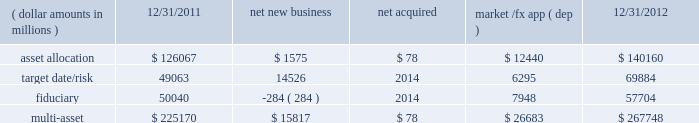Although many clients use both active and passive strategies , the application of these strategies differs greatly .
For example , clients may use index products to gain exposure to a market or asset class pending reallocation to an active manager .
This has the effect of increasing turnover of index aum .
In addition , institutional non-etp index assignments tend to be very large ( multi- billion dollars ) and typically reflect low fee rates .
This has the potential to exaggerate the significance of net flows in institutional index products on blackrock 2019s revenues and earnings .
Equity year-end 2012 equity aum of $ 1.845 trillion increased by $ 285.4 billion , or 18% ( 18 % ) , from the end of 2011 , largely due to flows into regional , country-specific and global mandates and the effect of higher market valuations .
Equity aum growth included $ 54.0 billion in net new business and $ 3.6 billion in new assets related to the acquisition of claymore .
Net new business of $ 54.0 billion was driven by net inflows of $ 53.0 billion and $ 19.1 billion into ishares and non-etp index accounts , respectively .
Passive inflows were offset by active net outflows of $ 18.1 billion , with net outflows of $ 10.0 billion and $ 8.1 billion from fundamental and scientific active equity products , respectively .
Passive strategies represented 84% ( 84 % ) of equity aum with the remaining 16% ( 16 % ) in active mandates .
Institutional investors represented 62% ( 62 % ) of equity aum , while ishares , and retail and hnw represented 29% ( 29 % ) and 9% ( 9 % ) , respectively .
At year-end 2012 , 63% ( 63 % ) of equity aum was managed for clients in the americas ( defined as the united states , caribbean , canada , latin america and iberia ) compared with 28% ( 28 % ) and 9% ( 9 % ) managed for clients in emea and asia-pacific , respectively .
Blackrock 2019s effective fee rates fluctuate due to changes in aum mix .
Approximately half of blackrock 2019s equity aum is tied to international markets , including emerging markets , which tend to have higher fee rates than similar u.s .
Equity strategies .
Accordingly , fluctuations in international equity markets , which do not consistently move in tandem with u.s .
Markets , may have a greater impact on blackrock 2019s effective equity fee rates and revenues .
Fixed income fixed income aum ended 2012 at $ 1.259 trillion , rising $ 11.6 billion , or 1% ( 1 % ) , relative to december 31 , 2011 .
Growth in aum reflected $ 43.3 billion in net new business , excluding the two large previously mentioned low-fee outflows , $ 75.4 billion in market and foreign exchange gains and $ 3.0 billion in new assets related to claymore .
Net new business was led by flows into domestic specialty and global bond mandates , with net inflows of $ 28.8 billion , $ 13.6 billion and $ 3.1 billion into ishares , non-etp index and model-based products , respectively , partially offset by net outflows of $ 2.2 billion from fundamental strategies .
Fixed income aum was split between passive and active strategies with 48% ( 48 % ) and 52% ( 52 % ) , respectively .
Institutional investors represented 74% ( 74 % ) of fixed income aum while ishares and retail and hnw represented 15% ( 15 % ) and 11% ( 11 % ) , respectively .
At year-end 2012 , 59% ( 59 % ) of fixed income aum was managed for clients in the americas compared with 33% ( 33 % ) and 8% ( 8 % ) managed for clients in emea and asia- pacific , respectively .
Multi-asset class component changes in multi-asset class aum ( dollar amounts in millions ) 12/31/2011 net new business acquired market /fx app ( dep ) 12/31/2012 .
Multi-asset class aum totaled $ 267.7 billion at year-end 2012 , up 19% ( 19 % ) , or $ 42.6 billion , reflecting $ 15.8 billion in net new business and $ 26.7 billion in portfolio valuation gains .
Blackrock 2019s multi-asset class team manages a variety of bespoke mandates for a diversified client base that leverages our broad investment expertise in global equities , currencies , bonds and commodities , and our extensive risk management capabilities .
Investment solutions might include a combination of long-only portfolios and alternative investments as well as tactical asset allocation overlays .
At december 31 , 2012 , institutional investors represented 66% ( 66 % ) of multi-asset class aum , while retail and hnw accounted for the remaining aum .
Additionally , 58% ( 58 % ) of multi-asset class aum is managed for clients based in the americas with 37% ( 37 % ) and 5% ( 5 % ) managed for clients in emea and asia-pacific , respectively .
Flows reflected ongoing institutional demand for our advice in an increasingly .
What portion of the total multi-assets is related to asset allocation as of december 31 , 2012? 
Computations: (140160 / 267748)
Answer: 0.52348. 